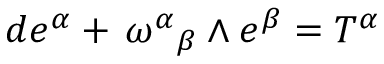Convert formula to latex. <formula><loc_0><loc_0><loc_500><loc_500>d e ^ { \alpha } + { { \, \omega } ^ { \alpha } } _ { \beta } \wedge e ^ { \beta } = T ^ { \alpha }</formula> 